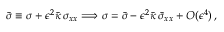<formula> <loc_0><loc_0><loc_500><loc_500>\bar { \sigma } \equiv \sigma + \epsilon ^ { 2 } \bar { \kappa } \, \sigma _ { x x } \Longrightarrow \sigma = \bar { \sigma } - \epsilon ^ { 2 } \bar { \kappa } \, \bar { \sigma } _ { x x } + O ( \epsilon ^ { 4 } ) \, ,</formula> 